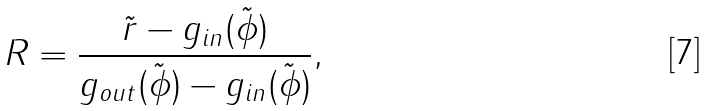Convert formula to latex. <formula><loc_0><loc_0><loc_500><loc_500>R = \frac { \tilde { r } - g _ { i n } ( \tilde { \phi } ) } { g _ { o u t } ( \tilde { \phi } ) - g _ { i n } ( \tilde { \phi } ) } ,</formula> 